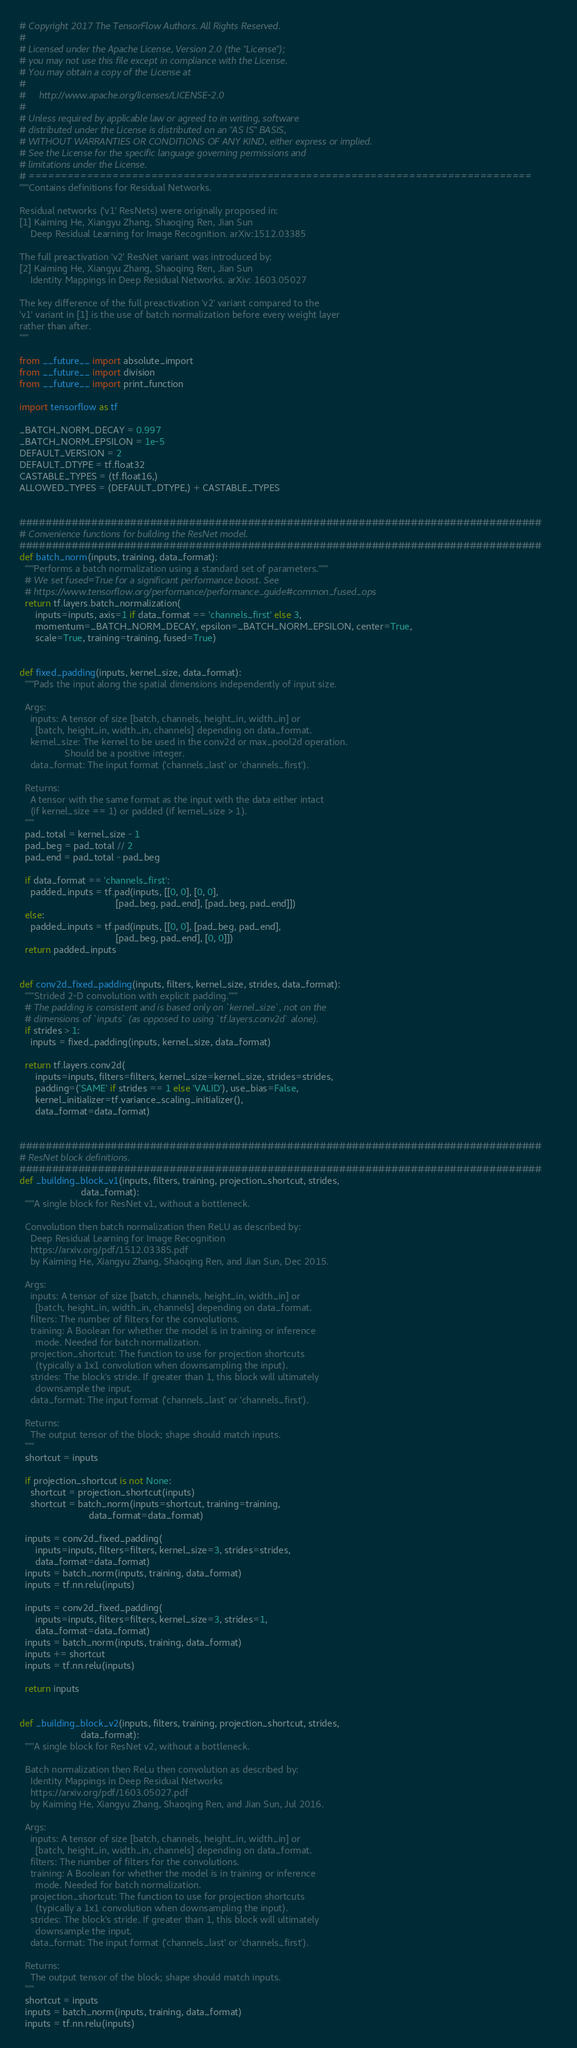Convert code to text. <code><loc_0><loc_0><loc_500><loc_500><_Python_># Copyright 2017 The TensorFlow Authors. All Rights Reserved.
#
# Licensed under the Apache License, Version 2.0 (the "License");
# you may not use this file except in compliance with the License.
# You may obtain a copy of the License at
#
#     http://www.apache.org/licenses/LICENSE-2.0
#
# Unless required by applicable law or agreed to in writing, software
# distributed under the License is distributed on an "AS IS" BASIS,
# WITHOUT WARRANTIES OR CONDITIONS OF ANY KIND, either express or implied.
# See the License for the specific language governing permissions and
# limitations under the License.
# ==============================================================================
"""Contains definitions for Residual Networks.

Residual networks ('v1' ResNets) were originally proposed in:
[1] Kaiming He, Xiangyu Zhang, Shaoqing Ren, Jian Sun
    Deep Residual Learning for Image Recognition. arXiv:1512.03385

The full preactivation 'v2' ResNet variant was introduced by:
[2] Kaiming He, Xiangyu Zhang, Shaoqing Ren, Jian Sun
    Identity Mappings in Deep Residual Networks. arXiv: 1603.05027

The key difference of the full preactivation 'v2' variant compared to the
'v1' variant in [1] is the use of batch normalization before every weight layer
rather than after.
"""

from __future__ import absolute_import
from __future__ import division
from __future__ import print_function

import tensorflow as tf

_BATCH_NORM_DECAY = 0.997
_BATCH_NORM_EPSILON = 1e-5
DEFAULT_VERSION = 2
DEFAULT_DTYPE = tf.float32
CASTABLE_TYPES = (tf.float16,)
ALLOWED_TYPES = (DEFAULT_DTYPE,) + CASTABLE_TYPES


################################################################################
# Convenience functions for building the ResNet model.
################################################################################
def batch_norm(inputs, training, data_format):
  """Performs a batch normalization using a standard set of parameters."""
  # We set fused=True for a significant performance boost. See
  # https://www.tensorflow.org/performance/performance_guide#common_fused_ops
  return tf.layers.batch_normalization(
      inputs=inputs, axis=1 if data_format == 'channels_first' else 3,
      momentum=_BATCH_NORM_DECAY, epsilon=_BATCH_NORM_EPSILON, center=True,
      scale=True, training=training, fused=True)


def fixed_padding(inputs, kernel_size, data_format):
  """Pads the input along the spatial dimensions independently of input size.

  Args:
    inputs: A tensor of size [batch, channels, height_in, width_in] or
      [batch, height_in, width_in, channels] depending on data_format.
    kernel_size: The kernel to be used in the conv2d or max_pool2d operation.
                 Should be a positive integer.
    data_format: The input format ('channels_last' or 'channels_first').

  Returns:
    A tensor with the same format as the input with the data either intact
    (if kernel_size == 1) or padded (if kernel_size > 1).
  """
  pad_total = kernel_size - 1
  pad_beg = pad_total // 2
  pad_end = pad_total - pad_beg

  if data_format == 'channels_first':
    padded_inputs = tf.pad(inputs, [[0, 0], [0, 0],
                                    [pad_beg, pad_end], [pad_beg, pad_end]])
  else:
    padded_inputs = tf.pad(inputs, [[0, 0], [pad_beg, pad_end],
                                    [pad_beg, pad_end], [0, 0]])
  return padded_inputs


def conv2d_fixed_padding(inputs, filters, kernel_size, strides, data_format):
  """Strided 2-D convolution with explicit padding."""
  # The padding is consistent and is based only on `kernel_size`, not on the
  # dimensions of `inputs` (as opposed to using `tf.layers.conv2d` alone).
  if strides > 1:
    inputs = fixed_padding(inputs, kernel_size, data_format)

  return tf.layers.conv2d(
      inputs=inputs, filters=filters, kernel_size=kernel_size, strides=strides,
      padding=('SAME' if strides == 1 else 'VALID'), use_bias=False,
      kernel_initializer=tf.variance_scaling_initializer(),
      data_format=data_format)


################################################################################
# ResNet block definitions.
################################################################################
def _building_block_v1(inputs, filters, training, projection_shortcut, strides,
                       data_format):
  """A single block for ResNet v1, without a bottleneck.

  Convolution then batch normalization then ReLU as described by:
    Deep Residual Learning for Image Recognition
    https://arxiv.org/pdf/1512.03385.pdf
    by Kaiming He, Xiangyu Zhang, Shaoqing Ren, and Jian Sun, Dec 2015.

  Args:
    inputs: A tensor of size [batch, channels, height_in, width_in] or
      [batch, height_in, width_in, channels] depending on data_format.
    filters: The number of filters for the convolutions.
    training: A Boolean for whether the model is in training or inference
      mode. Needed for batch normalization.
    projection_shortcut: The function to use for projection shortcuts
      (typically a 1x1 convolution when downsampling the input).
    strides: The block's stride. If greater than 1, this block will ultimately
      downsample the input.
    data_format: The input format ('channels_last' or 'channels_first').

  Returns:
    The output tensor of the block; shape should match inputs.
  """
  shortcut = inputs

  if projection_shortcut is not None:
    shortcut = projection_shortcut(inputs)
    shortcut = batch_norm(inputs=shortcut, training=training,
                          data_format=data_format)

  inputs = conv2d_fixed_padding(
      inputs=inputs, filters=filters, kernel_size=3, strides=strides,
      data_format=data_format)
  inputs = batch_norm(inputs, training, data_format)
  inputs = tf.nn.relu(inputs)

  inputs = conv2d_fixed_padding(
      inputs=inputs, filters=filters, kernel_size=3, strides=1,
      data_format=data_format)
  inputs = batch_norm(inputs, training, data_format)
  inputs += shortcut
  inputs = tf.nn.relu(inputs)

  return inputs


def _building_block_v2(inputs, filters, training, projection_shortcut, strides,
                       data_format):
  """A single block for ResNet v2, without a bottleneck.

  Batch normalization then ReLu then convolution as described by:
    Identity Mappings in Deep Residual Networks
    https://arxiv.org/pdf/1603.05027.pdf
    by Kaiming He, Xiangyu Zhang, Shaoqing Ren, and Jian Sun, Jul 2016.

  Args:
    inputs: A tensor of size [batch, channels, height_in, width_in] or
      [batch, height_in, width_in, channels] depending on data_format.
    filters: The number of filters for the convolutions.
    training: A Boolean for whether the model is in training or inference
      mode. Needed for batch normalization.
    projection_shortcut: The function to use for projection shortcuts
      (typically a 1x1 convolution when downsampling the input).
    strides: The block's stride. If greater than 1, this block will ultimately
      downsample the input.
    data_format: The input format ('channels_last' or 'channels_first').

  Returns:
    The output tensor of the block; shape should match inputs.
  """
  shortcut = inputs
  inputs = batch_norm(inputs, training, data_format)
  inputs = tf.nn.relu(inputs)
</code> 